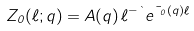<formula> <loc_0><loc_0><loc_500><loc_500>Z _ { 0 } ( \ell ; q ) = A ( q ) \, \ell ^ { - \theta } e ^ { \mu _ { 0 } ( q ) \ell }</formula> 